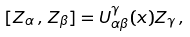<formula> <loc_0><loc_0><loc_500><loc_500>[ Z _ { \alpha } \, , \, Z _ { \beta } ] = U _ { \alpha \beta } ^ { \gamma } ( x ) Z _ { \gamma } \, ,</formula> 